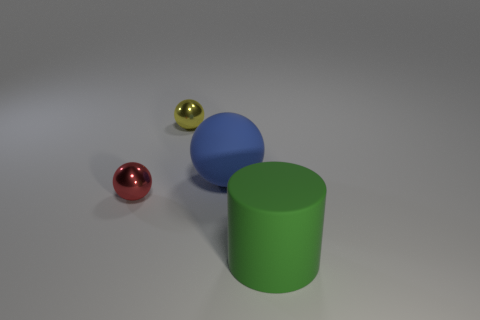Does the tiny red metal object have the same shape as the rubber thing that is in front of the tiny red thing?
Ensure brevity in your answer.  No. The big thing that is on the left side of the thing that is in front of the metal object on the left side of the yellow thing is made of what material?
Your response must be concise. Rubber. Is there a green object of the same size as the blue rubber object?
Offer a very short reply. Yes. There is a thing that is made of the same material as the blue ball; what size is it?
Offer a very short reply. Large. What shape is the red metal thing?
Offer a very short reply. Sphere. Are the large blue thing and the tiny thing that is left of the yellow sphere made of the same material?
Provide a short and direct response. No. How many things are either big objects or tiny shiny balls?
Give a very brief answer. 4. Are any big green balls visible?
Your response must be concise. No. What is the shape of the small thing that is behind the small sphere that is in front of the big blue ball?
Ensure brevity in your answer.  Sphere. How many things are either small things that are to the left of the yellow thing or red things that are left of the large green thing?
Keep it short and to the point. 1. 